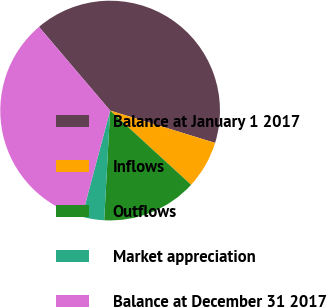Convert chart. <chart><loc_0><loc_0><loc_500><loc_500><pie_chart><fcel>Balance at January 1 2017<fcel>Inflows<fcel>Outflows<fcel>Market appreciation<fcel>Balance at December 31 2017<nl><fcel>40.97%<fcel>7.05%<fcel>14.05%<fcel>3.28%<fcel>34.65%<nl></chart> 